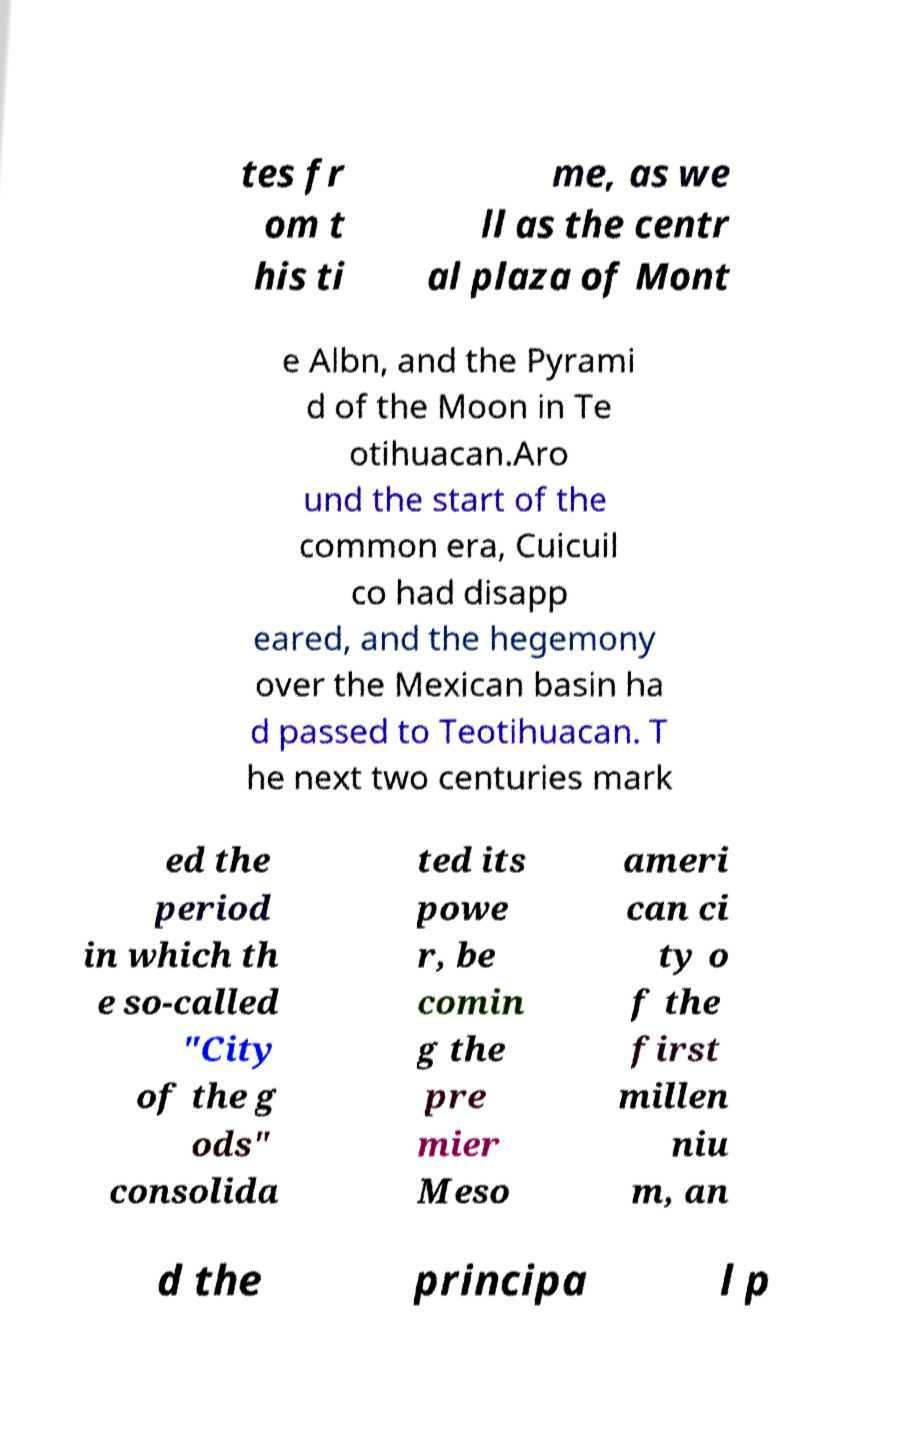For documentation purposes, I need the text within this image transcribed. Could you provide that? tes fr om t his ti me, as we ll as the centr al plaza of Mont e Albn, and the Pyrami d of the Moon in Te otihuacan.Aro und the start of the common era, Cuicuil co had disapp eared, and the hegemony over the Mexican basin ha d passed to Teotihuacan. T he next two centuries mark ed the period in which th e so-called "City of the g ods" consolida ted its powe r, be comin g the pre mier Meso ameri can ci ty o f the first millen niu m, an d the principa l p 